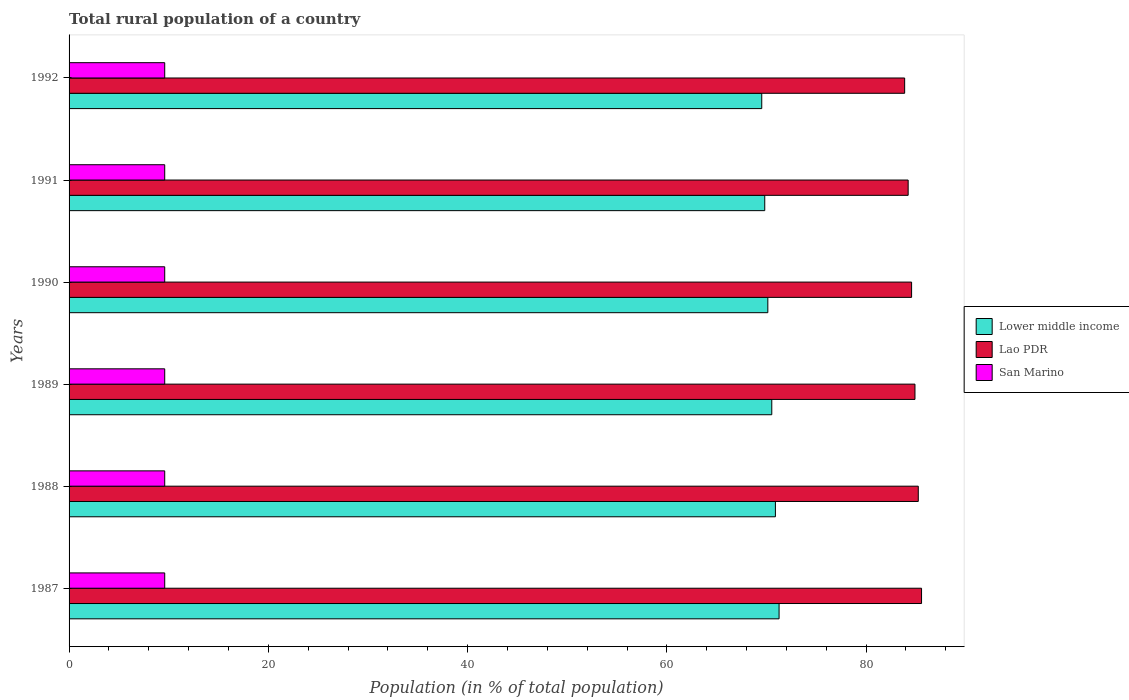Are the number of bars on each tick of the Y-axis equal?
Ensure brevity in your answer.  Yes. How many bars are there on the 2nd tick from the top?
Offer a terse response. 3. What is the label of the 5th group of bars from the top?
Your response must be concise. 1988. What is the rural population in Lao PDR in 1992?
Provide a short and direct response. 83.87. Across all years, what is the maximum rural population in Lower middle income?
Your answer should be very brief. 71.26. Across all years, what is the minimum rural population in Lower middle income?
Offer a terse response. 69.52. In which year was the rural population in San Marino maximum?
Make the answer very short. 1987. What is the total rural population in Lao PDR in the graph?
Give a very brief answer. 508.34. What is the difference between the rural population in Lower middle income in 1987 and that in 1988?
Keep it short and to the point. 0.37. What is the difference between the rural population in Lao PDR in 1992 and the rural population in Lower middle income in 1987?
Ensure brevity in your answer.  12.6. What is the average rural population in San Marino per year?
Offer a very short reply. 9.6. In the year 1990, what is the difference between the rural population in San Marino and rural population in Lower middle income?
Provide a succinct answer. -60.53. What is the ratio of the rural population in Lao PDR in 1987 to that in 1988?
Provide a succinct answer. 1. Is the difference between the rural population in San Marino in 1989 and 1990 greater than the difference between the rural population in Lower middle income in 1989 and 1990?
Make the answer very short. No. What is the difference between the highest and the second highest rural population in Lao PDR?
Your answer should be very brief. 0.33. What is the difference between the highest and the lowest rural population in San Marino?
Provide a short and direct response. 0. Is the sum of the rural population in San Marino in 1988 and 1991 greater than the maximum rural population in Lower middle income across all years?
Keep it short and to the point. No. What does the 1st bar from the top in 1990 represents?
Offer a very short reply. San Marino. What does the 2nd bar from the bottom in 1991 represents?
Ensure brevity in your answer.  Lao PDR. Is it the case that in every year, the sum of the rural population in San Marino and rural population in Lower middle income is greater than the rural population in Lao PDR?
Keep it short and to the point. No. Are all the bars in the graph horizontal?
Your answer should be compact. Yes. Are the values on the major ticks of X-axis written in scientific E-notation?
Give a very brief answer. No. Does the graph contain any zero values?
Your answer should be compact. No. Does the graph contain grids?
Ensure brevity in your answer.  No. Where does the legend appear in the graph?
Your response must be concise. Center right. How are the legend labels stacked?
Your response must be concise. Vertical. What is the title of the graph?
Make the answer very short. Total rural population of a country. What is the label or title of the X-axis?
Your answer should be compact. Population (in % of total population). What is the Population (in % of total population) in Lower middle income in 1987?
Make the answer very short. 71.26. What is the Population (in % of total population) of Lao PDR in 1987?
Provide a short and direct response. 85.56. What is the Population (in % of total population) of San Marino in 1987?
Offer a terse response. 9.6. What is the Population (in % of total population) of Lower middle income in 1988?
Ensure brevity in your answer.  70.89. What is the Population (in % of total population) of Lao PDR in 1988?
Keep it short and to the point. 85.23. What is the Population (in % of total population) in San Marino in 1988?
Provide a short and direct response. 9.6. What is the Population (in % of total population) of Lower middle income in 1989?
Your answer should be compact. 70.53. What is the Population (in % of total population) of Lao PDR in 1989?
Provide a short and direct response. 84.9. What is the Population (in % of total population) in San Marino in 1989?
Offer a terse response. 9.6. What is the Population (in % of total population) in Lower middle income in 1990?
Your answer should be compact. 70.13. What is the Population (in % of total population) in Lao PDR in 1990?
Your response must be concise. 84.56. What is the Population (in % of total population) in San Marino in 1990?
Offer a very short reply. 9.6. What is the Population (in % of total population) of Lower middle income in 1991?
Offer a very short reply. 69.82. What is the Population (in % of total population) of Lao PDR in 1991?
Provide a succinct answer. 84.22. What is the Population (in % of total population) in San Marino in 1991?
Give a very brief answer. 9.6. What is the Population (in % of total population) in Lower middle income in 1992?
Keep it short and to the point. 69.52. What is the Population (in % of total population) in Lao PDR in 1992?
Offer a very short reply. 83.87. What is the Population (in % of total population) in San Marino in 1992?
Provide a succinct answer. 9.6. Across all years, what is the maximum Population (in % of total population) of Lower middle income?
Keep it short and to the point. 71.26. Across all years, what is the maximum Population (in % of total population) in Lao PDR?
Make the answer very short. 85.56. Across all years, what is the maximum Population (in % of total population) in San Marino?
Make the answer very short. 9.6. Across all years, what is the minimum Population (in % of total population) of Lower middle income?
Provide a succinct answer. 69.52. Across all years, what is the minimum Population (in % of total population) in Lao PDR?
Your answer should be very brief. 83.87. Across all years, what is the minimum Population (in % of total population) in San Marino?
Offer a terse response. 9.6. What is the total Population (in % of total population) of Lower middle income in the graph?
Offer a terse response. 422.16. What is the total Population (in % of total population) in Lao PDR in the graph?
Give a very brief answer. 508.35. What is the total Population (in % of total population) in San Marino in the graph?
Keep it short and to the point. 57.6. What is the difference between the Population (in % of total population) in Lower middle income in 1987 and that in 1988?
Keep it short and to the point. 0.37. What is the difference between the Population (in % of total population) of Lao PDR in 1987 and that in 1988?
Offer a very short reply. 0.33. What is the difference between the Population (in % of total population) in San Marino in 1987 and that in 1988?
Provide a short and direct response. 0. What is the difference between the Population (in % of total population) in Lower middle income in 1987 and that in 1989?
Give a very brief answer. 0.73. What is the difference between the Population (in % of total population) in Lao PDR in 1987 and that in 1989?
Offer a very short reply. 0.66. What is the difference between the Population (in % of total population) in San Marino in 1987 and that in 1989?
Ensure brevity in your answer.  0. What is the difference between the Population (in % of total population) in Lower middle income in 1987 and that in 1990?
Keep it short and to the point. 1.13. What is the difference between the Population (in % of total population) in Lower middle income in 1987 and that in 1991?
Offer a very short reply. 1.44. What is the difference between the Population (in % of total population) of Lao PDR in 1987 and that in 1991?
Ensure brevity in your answer.  1.34. What is the difference between the Population (in % of total population) in San Marino in 1987 and that in 1991?
Provide a succinct answer. 0. What is the difference between the Population (in % of total population) of Lower middle income in 1987 and that in 1992?
Offer a terse response. 1.74. What is the difference between the Population (in % of total population) of Lao PDR in 1987 and that in 1992?
Your answer should be compact. 1.69. What is the difference between the Population (in % of total population) of San Marino in 1987 and that in 1992?
Provide a succinct answer. 0. What is the difference between the Population (in % of total population) of Lower middle income in 1988 and that in 1989?
Ensure brevity in your answer.  0.36. What is the difference between the Population (in % of total population) of Lao PDR in 1988 and that in 1989?
Offer a very short reply. 0.33. What is the difference between the Population (in % of total population) of Lower middle income in 1988 and that in 1990?
Your answer should be very brief. 0.76. What is the difference between the Population (in % of total population) of Lao PDR in 1988 and that in 1990?
Offer a very short reply. 0.67. What is the difference between the Population (in % of total population) of San Marino in 1988 and that in 1990?
Provide a short and direct response. 0. What is the difference between the Population (in % of total population) of Lower middle income in 1988 and that in 1991?
Give a very brief answer. 1.07. What is the difference between the Population (in % of total population) in Lao PDR in 1988 and that in 1991?
Make the answer very short. 1.02. What is the difference between the Population (in % of total population) in San Marino in 1988 and that in 1991?
Make the answer very short. 0. What is the difference between the Population (in % of total population) in Lower middle income in 1988 and that in 1992?
Give a very brief answer. 1.37. What is the difference between the Population (in % of total population) in Lao PDR in 1988 and that in 1992?
Keep it short and to the point. 1.37. What is the difference between the Population (in % of total population) in Lower middle income in 1989 and that in 1990?
Ensure brevity in your answer.  0.4. What is the difference between the Population (in % of total population) in Lao PDR in 1989 and that in 1990?
Keep it short and to the point. 0.34. What is the difference between the Population (in % of total population) in San Marino in 1989 and that in 1990?
Your answer should be compact. 0. What is the difference between the Population (in % of total population) in Lower middle income in 1989 and that in 1991?
Ensure brevity in your answer.  0.71. What is the difference between the Population (in % of total population) of Lao PDR in 1989 and that in 1991?
Your response must be concise. 0.68. What is the difference between the Population (in % of total population) in Lower middle income in 1989 and that in 1992?
Give a very brief answer. 1.01. What is the difference between the Population (in % of total population) of Lao PDR in 1989 and that in 1992?
Your response must be concise. 1.03. What is the difference between the Population (in % of total population) in San Marino in 1989 and that in 1992?
Provide a short and direct response. 0. What is the difference between the Population (in % of total population) of Lower middle income in 1990 and that in 1991?
Make the answer very short. 0.31. What is the difference between the Population (in % of total population) of Lao PDR in 1990 and that in 1991?
Keep it short and to the point. 0.34. What is the difference between the Population (in % of total population) in San Marino in 1990 and that in 1991?
Offer a terse response. 0. What is the difference between the Population (in % of total population) of Lower middle income in 1990 and that in 1992?
Offer a very short reply. 0.61. What is the difference between the Population (in % of total population) in Lao PDR in 1990 and that in 1992?
Provide a short and direct response. 0.7. What is the difference between the Population (in % of total population) of Lower middle income in 1991 and that in 1992?
Make the answer very short. 0.3. What is the difference between the Population (in % of total population) of Lao PDR in 1991 and that in 1992?
Provide a succinct answer. 0.35. What is the difference between the Population (in % of total population) of San Marino in 1991 and that in 1992?
Provide a succinct answer. 0. What is the difference between the Population (in % of total population) in Lower middle income in 1987 and the Population (in % of total population) in Lao PDR in 1988?
Your answer should be very brief. -13.97. What is the difference between the Population (in % of total population) in Lower middle income in 1987 and the Population (in % of total population) in San Marino in 1988?
Provide a short and direct response. 61.66. What is the difference between the Population (in % of total population) of Lao PDR in 1987 and the Population (in % of total population) of San Marino in 1988?
Offer a terse response. 75.96. What is the difference between the Population (in % of total population) of Lower middle income in 1987 and the Population (in % of total population) of Lao PDR in 1989?
Ensure brevity in your answer.  -13.64. What is the difference between the Population (in % of total population) of Lower middle income in 1987 and the Population (in % of total population) of San Marino in 1989?
Your answer should be compact. 61.66. What is the difference between the Population (in % of total population) in Lao PDR in 1987 and the Population (in % of total population) in San Marino in 1989?
Offer a very short reply. 75.96. What is the difference between the Population (in % of total population) in Lower middle income in 1987 and the Population (in % of total population) in Lao PDR in 1990?
Provide a short and direct response. -13.3. What is the difference between the Population (in % of total population) in Lower middle income in 1987 and the Population (in % of total population) in San Marino in 1990?
Ensure brevity in your answer.  61.66. What is the difference between the Population (in % of total population) of Lao PDR in 1987 and the Population (in % of total population) of San Marino in 1990?
Your answer should be very brief. 75.96. What is the difference between the Population (in % of total population) of Lower middle income in 1987 and the Population (in % of total population) of Lao PDR in 1991?
Your response must be concise. -12.96. What is the difference between the Population (in % of total population) in Lower middle income in 1987 and the Population (in % of total population) in San Marino in 1991?
Your response must be concise. 61.66. What is the difference between the Population (in % of total population) in Lao PDR in 1987 and the Population (in % of total population) in San Marino in 1991?
Your answer should be compact. 75.96. What is the difference between the Population (in % of total population) of Lower middle income in 1987 and the Population (in % of total population) of Lao PDR in 1992?
Make the answer very short. -12.6. What is the difference between the Population (in % of total population) in Lower middle income in 1987 and the Population (in % of total population) in San Marino in 1992?
Ensure brevity in your answer.  61.66. What is the difference between the Population (in % of total population) of Lao PDR in 1987 and the Population (in % of total population) of San Marino in 1992?
Provide a short and direct response. 75.96. What is the difference between the Population (in % of total population) in Lower middle income in 1988 and the Population (in % of total population) in Lao PDR in 1989?
Keep it short and to the point. -14.01. What is the difference between the Population (in % of total population) of Lower middle income in 1988 and the Population (in % of total population) of San Marino in 1989?
Ensure brevity in your answer.  61.29. What is the difference between the Population (in % of total population) of Lao PDR in 1988 and the Population (in % of total population) of San Marino in 1989?
Ensure brevity in your answer.  75.63. What is the difference between the Population (in % of total population) of Lower middle income in 1988 and the Population (in % of total population) of Lao PDR in 1990?
Offer a terse response. -13.67. What is the difference between the Population (in % of total population) in Lower middle income in 1988 and the Population (in % of total population) in San Marino in 1990?
Your answer should be compact. 61.29. What is the difference between the Population (in % of total population) in Lao PDR in 1988 and the Population (in % of total population) in San Marino in 1990?
Provide a succinct answer. 75.63. What is the difference between the Population (in % of total population) in Lower middle income in 1988 and the Population (in % of total population) in Lao PDR in 1991?
Keep it short and to the point. -13.32. What is the difference between the Population (in % of total population) in Lower middle income in 1988 and the Population (in % of total population) in San Marino in 1991?
Your response must be concise. 61.29. What is the difference between the Population (in % of total population) of Lao PDR in 1988 and the Population (in % of total population) of San Marino in 1991?
Offer a terse response. 75.63. What is the difference between the Population (in % of total population) in Lower middle income in 1988 and the Population (in % of total population) in Lao PDR in 1992?
Make the answer very short. -12.97. What is the difference between the Population (in % of total population) of Lower middle income in 1988 and the Population (in % of total population) of San Marino in 1992?
Make the answer very short. 61.29. What is the difference between the Population (in % of total population) in Lao PDR in 1988 and the Population (in % of total population) in San Marino in 1992?
Keep it short and to the point. 75.63. What is the difference between the Population (in % of total population) in Lower middle income in 1989 and the Population (in % of total population) in Lao PDR in 1990?
Give a very brief answer. -14.03. What is the difference between the Population (in % of total population) of Lower middle income in 1989 and the Population (in % of total population) of San Marino in 1990?
Offer a very short reply. 60.93. What is the difference between the Population (in % of total population) in Lao PDR in 1989 and the Population (in % of total population) in San Marino in 1990?
Offer a terse response. 75.3. What is the difference between the Population (in % of total population) in Lower middle income in 1989 and the Population (in % of total population) in Lao PDR in 1991?
Make the answer very short. -13.69. What is the difference between the Population (in % of total population) of Lower middle income in 1989 and the Population (in % of total population) of San Marino in 1991?
Give a very brief answer. 60.93. What is the difference between the Population (in % of total population) in Lao PDR in 1989 and the Population (in % of total population) in San Marino in 1991?
Your response must be concise. 75.3. What is the difference between the Population (in % of total population) in Lower middle income in 1989 and the Population (in % of total population) in Lao PDR in 1992?
Ensure brevity in your answer.  -13.34. What is the difference between the Population (in % of total population) in Lower middle income in 1989 and the Population (in % of total population) in San Marino in 1992?
Provide a succinct answer. 60.93. What is the difference between the Population (in % of total population) of Lao PDR in 1989 and the Population (in % of total population) of San Marino in 1992?
Your answer should be very brief. 75.3. What is the difference between the Population (in % of total population) in Lower middle income in 1990 and the Population (in % of total population) in Lao PDR in 1991?
Make the answer very short. -14.09. What is the difference between the Population (in % of total population) of Lower middle income in 1990 and the Population (in % of total population) of San Marino in 1991?
Ensure brevity in your answer.  60.53. What is the difference between the Population (in % of total population) in Lao PDR in 1990 and the Population (in % of total population) in San Marino in 1991?
Keep it short and to the point. 74.96. What is the difference between the Population (in % of total population) in Lower middle income in 1990 and the Population (in % of total population) in Lao PDR in 1992?
Ensure brevity in your answer.  -13.73. What is the difference between the Population (in % of total population) of Lower middle income in 1990 and the Population (in % of total population) of San Marino in 1992?
Ensure brevity in your answer.  60.53. What is the difference between the Population (in % of total population) in Lao PDR in 1990 and the Population (in % of total population) in San Marino in 1992?
Provide a succinct answer. 74.96. What is the difference between the Population (in % of total population) of Lower middle income in 1991 and the Population (in % of total population) of Lao PDR in 1992?
Offer a terse response. -14.04. What is the difference between the Population (in % of total population) of Lower middle income in 1991 and the Population (in % of total population) of San Marino in 1992?
Offer a very short reply. 60.22. What is the difference between the Population (in % of total population) in Lao PDR in 1991 and the Population (in % of total population) in San Marino in 1992?
Your answer should be compact. 74.62. What is the average Population (in % of total population) in Lower middle income per year?
Give a very brief answer. 70.36. What is the average Population (in % of total population) of Lao PDR per year?
Your answer should be compact. 84.72. What is the average Population (in % of total population) of San Marino per year?
Your answer should be compact. 9.6. In the year 1987, what is the difference between the Population (in % of total population) in Lower middle income and Population (in % of total population) in Lao PDR?
Your answer should be compact. -14.3. In the year 1987, what is the difference between the Population (in % of total population) of Lower middle income and Population (in % of total population) of San Marino?
Keep it short and to the point. 61.66. In the year 1987, what is the difference between the Population (in % of total population) in Lao PDR and Population (in % of total population) in San Marino?
Provide a short and direct response. 75.96. In the year 1988, what is the difference between the Population (in % of total population) in Lower middle income and Population (in % of total population) in Lao PDR?
Offer a very short reply. -14.34. In the year 1988, what is the difference between the Population (in % of total population) of Lower middle income and Population (in % of total population) of San Marino?
Provide a succinct answer. 61.29. In the year 1988, what is the difference between the Population (in % of total population) in Lao PDR and Population (in % of total population) in San Marino?
Provide a succinct answer. 75.63. In the year 1989, what is the difference between the Population (in % of total population) of Lower middle income and Population (in % of total population) of Lao PDR?
Offer a terse response. -14.37. In the year 1989, what is the difference between the Population (in % of total population) in Lower middle income and Population (in % of total population) in San Marino?
Make the answer very short. 60.93. In the year 1989, what is the difference between the Population (in % of total population) of Lao PDR and Population (in % of total population) of San Marino?
Provide a short and direct response. 75.3. In the year 1990, what is the difference between the Population (in % of total population) of Lower middle income and Population (in % of total population) of Lao PDR?
Give a very brief answer. -14.43. In the year 1990, what is the difference between the Population (in % of total population) of Lower middle income and Population (in % of total population) of San Marino?
Provide a short and direct response. 60.53. In the year 1990, what is the difference between the Population (in % of total population) in Lao PDR and Population (in % of total population) in San Marino?
Give a very brief answer. 74.96. In the year 1991, what is the difference between the Population (in % of total population) in Lower middle income and Population (in % of total population) in Lao PDR?
Provide a succinct answer. -14.39. In the year 1991, what is the difference between the Population (in % of total population) of Lower middle income and Population (in % of total population) of San Marino?
Make the answer very short. 60.22. In the year 1991, what is the difference between the Population (in % of total population) in Lao PDR and Population (in % of total population) in San Marino?
Offer a very short reply. 74.62. In the year 1992, what is the difference between the Population (in % of total population) in Lower middle income and Population (in % of total population) in Lao PDR?
Your response must be concise. -14.34. In the year 1992, what is the difference between the Population (in % of total population) of Lower middle income and Population (in % of total population) of San Marino?
Offer a very short reply. 59.92. In the year 1992, what is the difference between the Population (in % of total population) of Lao PDR and Population (in % of total population) of San Marino?
Your answer should be compact. 74.27. What is the ratio of the Population (in % of total population) in Lower middle income in 1987 to that in 1988?
Give a very brief answer. 1.01. What is the ratio of the Population (in % of total population) in Lao PDR in 1987 to that in 1988?
Keep it short and to the point. 1. What is the ratio of the Population (in % of total population) in San Marino in 1987 to that in 1988?
Give a very brief answer. 1. What is the ratio of the Population (in % of total population) of Lower middle income in 1987 to that in 1989?
Offer a very short reply. 1.01. What is the ratio of the Population (in % of total population) in Lower middle income in 1987 to that in 1990?
Your answer should be compact. 1.02. What is the ratio of the Population (in % of total population) of Lao PDR in 1987 to that in 1990?
Offer a terse response. 1.01. What is the ratio of the Population (in % of total population) in San Marino in 1987 to that in 1990?
Offer a terse response. 1. What is the ratio of the Population (in % of total population) of Lower middle income in 1987 to that in 1991?
Make the answer very short. 1.02. What is the ratio of the Population (in % of total population) of Lao PDR in 1987 to that in 1991?
Offer a terse response. 1.02. What is the ratio of the Population (in % of total population) in San Marino in 1987 to that in 1991?
Give a very brief answer. 1. What is the ratio of the Population (in % of total population) of Lower middle income in 1987 to that in 1992?
Ensure brevity in your answer.  1.02. What is the ratio of the Population (in % of total population) of Lao PDR in 1987 to that in 1992?
Offer a very short reply. 1.02. What is the ratio of the Population (in % of total population) of Lower middle income in 1988 to that in 1989?
Your answer should be compact. 1.01. What is the ratio of the Population (in % of total population) of San Marino in 1988 to that in 1989?
Your answer should be compact. 1. What is the ratio of the Population (in % of total population) of Lower middle income in 1988 to that in 1990?
Offer a very short reply. 1.01. What is the ratio of the Population (in % of total population) of Lao PDR in 1988 to that in 1990?
Give a very brief answer. 1.01. What is the ratio of the Population (in % of total population) in Lower middle income in 1988 to that in 1991?
Give a very brief answer. 1.02. What is the ratio of the Population (in % of total population) in Lao PDR in 1988 to that in 1991?
Ensure brevity in your answer.  1.01. What is the ratio of the Population (in % of total population) in Lower middle income in 1988 to that in 1992?
Provide a short and direct response. 1.02. What is the ratio of the Population (in % of total population) in Lao PDR in 1988 to that in 1992?
Give a very brief answer. 1.02. What is the ratio of the Population (in % of total population) in San Marino in 1988 to that in 1992?
Keep it short and to the point. 1. What is the ratio of the Population (in % of total population) of Lao PDR in 1989 to that in 1990?
Provide a short and direct response. 1. What is the ratio of the Population (in % of total population) of Lower middle income in 1989 to that in 1991?
Your response must be concise. 1.01. What is the ratio of the Population (in % of total population) of Lower middle income in 1989 to that in 1992?
Ensure brevity in your answer.  1.01. What is the ratio of the Population (in % of total population) in Lao PDR in 1989 to that in 1992?
Provide a short and direct response. 1.01. What is the ratio of the Population (in % of total population) in San Marino in 1989 to that in 1992?
Your answer should be compact. 1. What is the ratio of the Population (in % of total population) in San Marino in 1990 to that in 1991?
Your answer should be very brief. 1. What is the ratio of the Population (in % of total population) of Lower middle income in 1990 to that in 1992?
Offer a terse response. 1.01. What is the ratio of the Population (in % of total population) of Lao PDR in 1990 to that in 1992?
Offer a very short reply. 1.01. What is the ratio of the Population (in % of total population) in San Marino in 1990 to that in 1992?
Your response must be concise. 1. What is the ratio of the Population (in % of total population) in Lower middle income in 1991 to that in 1992?
Offer a terse response. 1. What is the ratio of the Population (in % of total population) in Lao PDR in 1991 to that in 1992?
Your answer should be very brief. 1. What is the difference between the highest and the second highest Population (in % of total population) in Lower middle income?
Offer a very short reply. 0.37. What is the difference between the highest and the second highest Population (in % of total population) in Lao PDR?
Give a very brief answer. 0.33. What is the difference between the highest and the lowest Population (in % of total population) of Lower middle income?
Provide a short and direct response. 1.74. What is the difference between the highest and the lowest Population (in % of total population) of Lao PDR?
Your response must be concise. 1.69. 